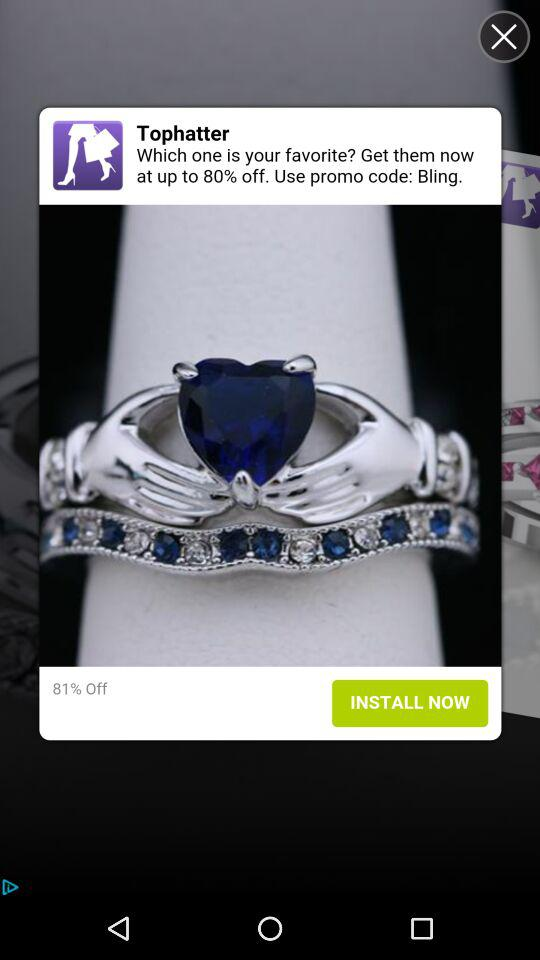What is the percentage discount on the ring?
Answer the question using a single word or phrase. 81% 